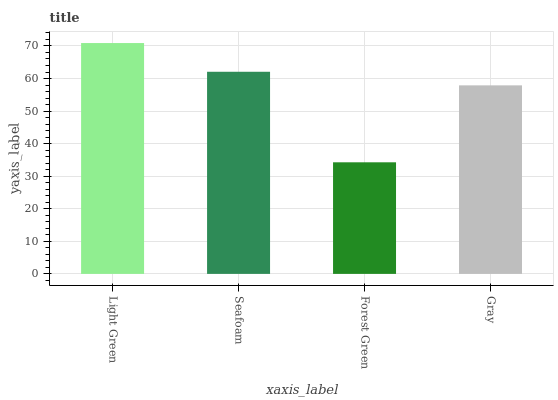Is Forest Green the minimum?
Answer yes or no. Yes. Is Light Green the maximum?
Answer yes or no. Yes. Is Seafoam the minimum?
Answer yes or no. No. Is Seafoam the maximum?
Answer yes or no. No. Is Light Green greater than Seafoam?
Answer yes or no. Yes. Is Seafoam less than Light Green?
Answer yes or no. Yes. Is Seafoam greater than Light Green?
Answer yes or no. No. Is Light Green less than Seafoam?
Answer yes or no. No. Is Seafoam the high median?
Answer yes or no. Yes. Is Gray the low median?
Answer yes or no. Yes. Is Gray the high median?
Answer yes or no. No. Is Light Green the low median?
Answer yes or no. No. 